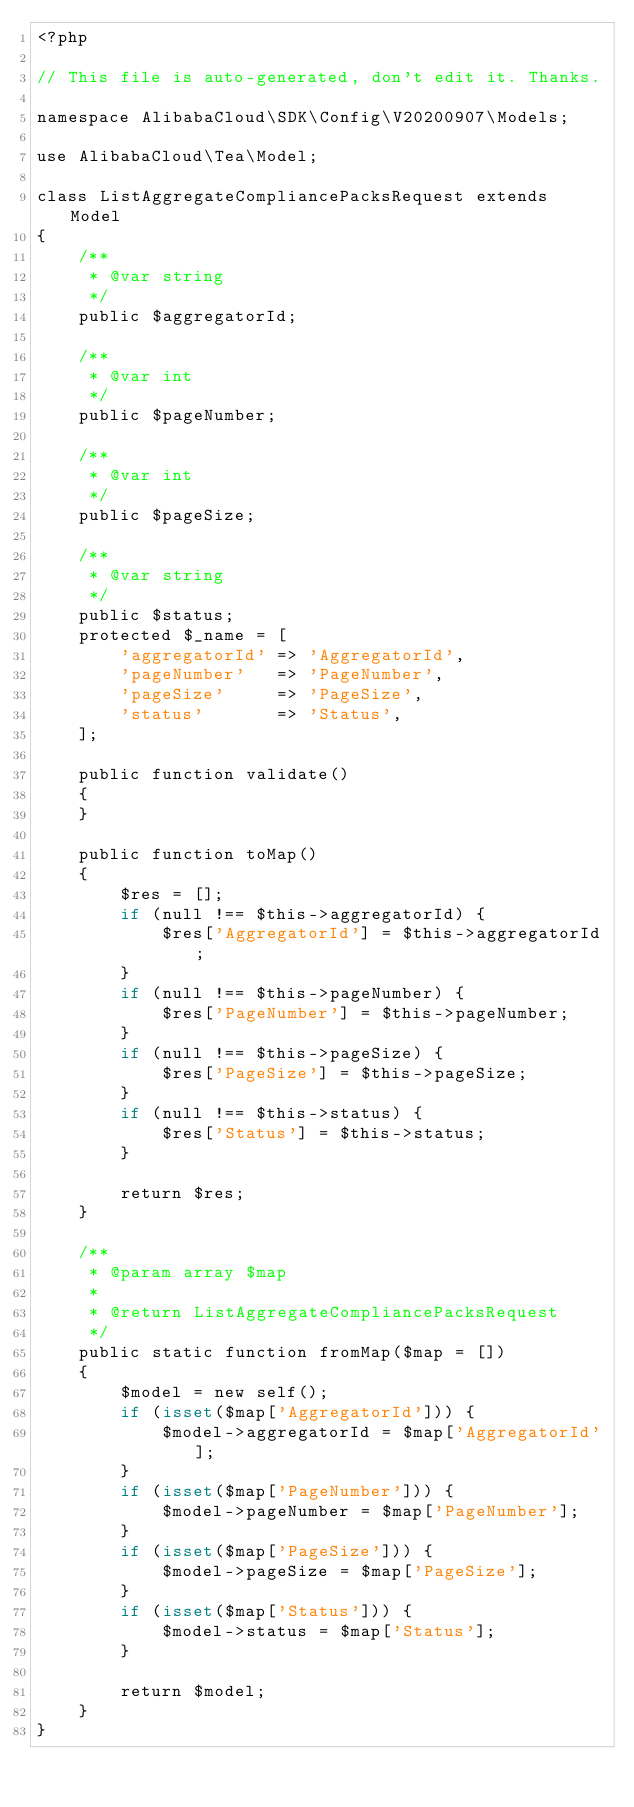<code> <loc_0><loc_0><loc_500><loc_500><_PHP_><?php

// This file is auto-generated, don't edit it. Thanks.

namespace AlibabaCloud\SDK\Config\V20200907\Models;

use AlibabaCloud\Tea\Model;

class ListAggregateCompliancePacksRequest extends Model
{
    /**
     * @var string
     */
    public $aggregatorId;

    /**
     * @var int
     */
    public $pageNumber;

    /**
     * @var int
     */
    public $pageSize;

    /**
     * @var string
     */
    public $status;
    protected $_name = [
        'aggregatorId' => 'AggregatorId',
        'pageNumber'   => 'PageNumber',
        'pageSize'     => 'PageSize',
        'status'       => 'Status',
    ];

    public function validate()
    {
    }

    public function toMap()
    {
        $res = [];
        if (null !== $this->aggregatorId) {
            $res['AggregatorId'] = $this->aggregatorId;
        }
        if (null !== $this->pageNumber) {
            $res['PageNumber'] = $this->pageNumber;
        }
        if (null !== $this->pageSize) {
            $res['PageSize'] = $this->pageSize;
        }
        if (null !== $this->status) {
            $res['Status'] = $this->status;
        }

        return $res;
    }

    /**
     * @param array $map
     *
     * @return ListAggregateCompliancePacksRequest
     */
    public static function fromMap($map = [])
    {
        $model = new self();
        if (isset($map['AggregatorId'])) {
            $model->aggregatorId = $map['AggregatorId'];
        }
        if (isset($map['PageNumber'])) {
            $model->pageNumber = $map['PageNumber'];
        }
        if (isset($map['PageSize'])) {
            $model->pageSize = $map['PageSize'];
        }
        if (isset($map['Status'])) {
            $model->status = $map['Status'];
        }

        return $model;
    }
}
</code> 